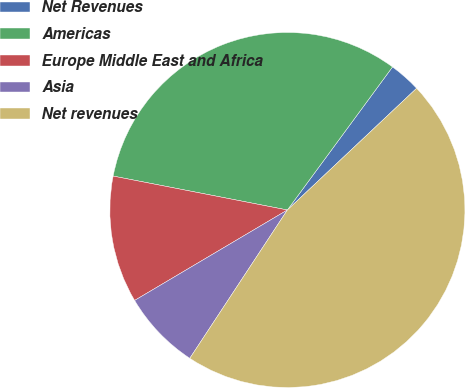<chart> <loc_0><loc_0><loc_500><loc_500><pie_chart><fcel>Net Revenues<fcel>Americas<fcel>Europe Middle East and Africa<fcel>Asia<fcel>Net revenues<nl><fcel>2.89%<fcel>32.03%<fcel>11.57%<fcel>7.23%<fcel>46.29%<nl></chart> 